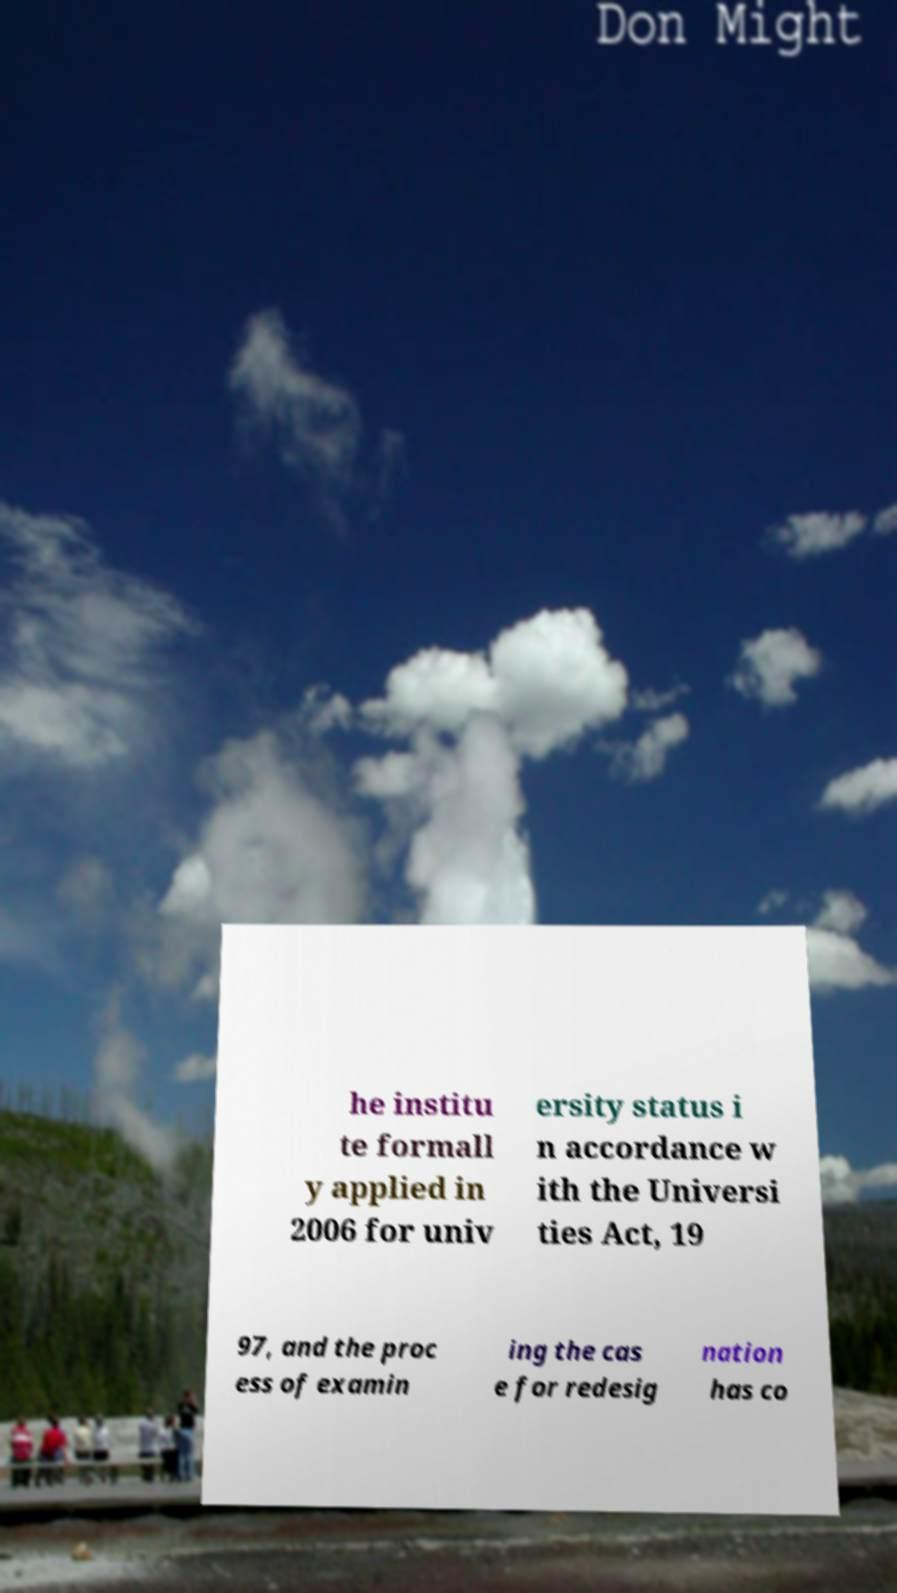Could you extract and type out the text from this image? he institu te formall y applied in 2006 for univ ersity status i n accordance w ith the Universi ties Act, 19 97, and the proc ess of examin ing the cas e for redesig nation has co 